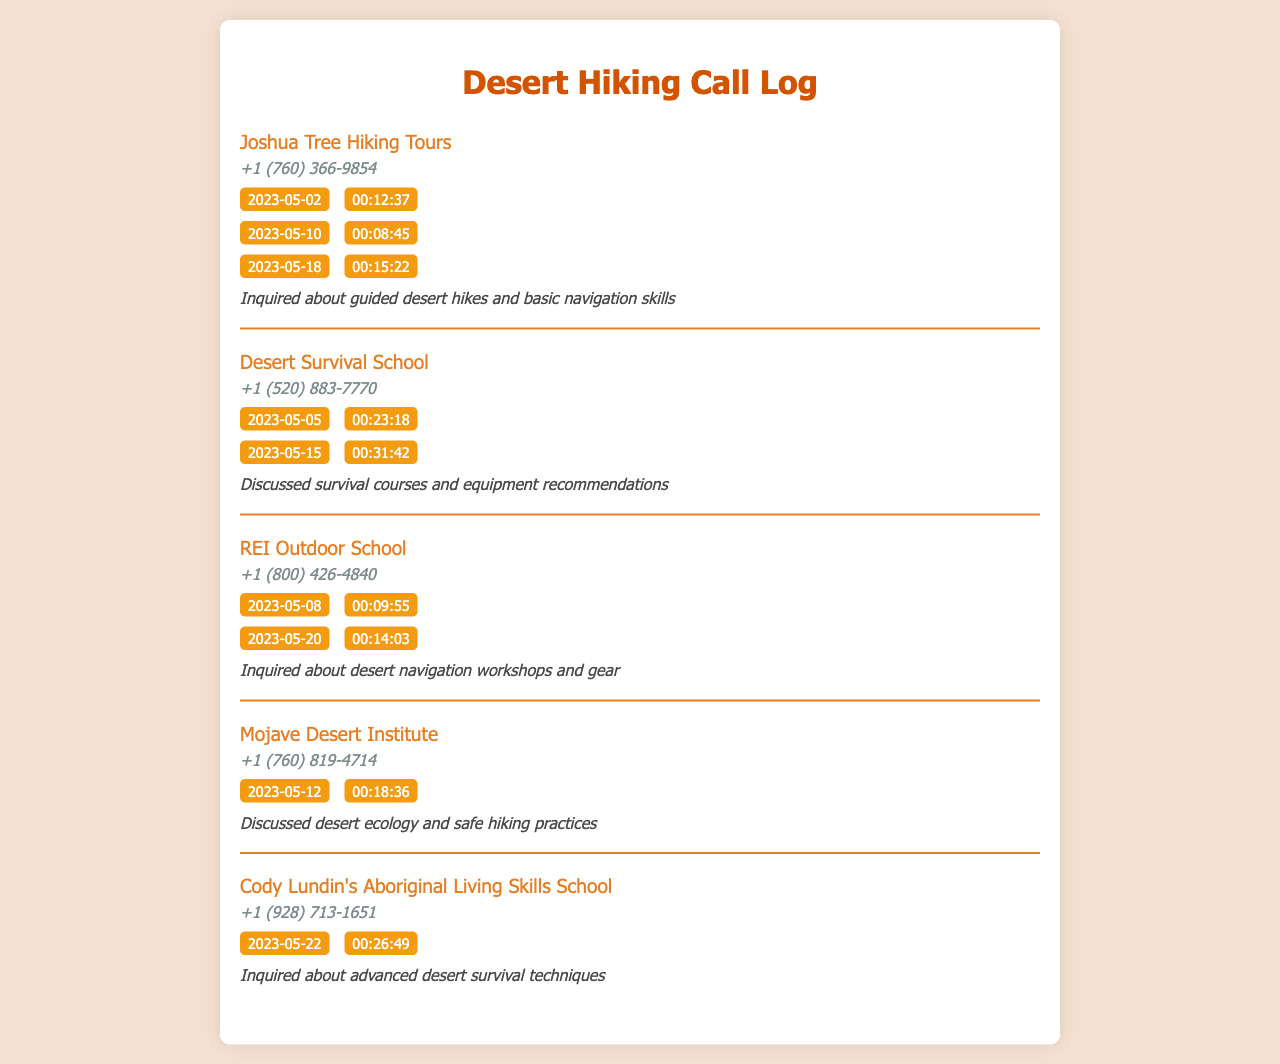What is the name of the first contact in the call log? The first contact in the call log is "Joshua Tree Hiking Tours".
Answer: Joshua Tree Hiking Tours How many total calls were made to the Desert Survival School? The Desert Survival School has two calls listed in the document.
Answer: 2 What is the duration of the longest call to Cody Lundin's Aboriginal Living Skills School? The longest call to Cody Lundin's Aboriginal Living Skills School lasted 26 minutes and 49 seconds.
Answer: 00:26:49 On what date was the last call made to REI Outdoor School? The last call to REI Outdoor School was made on May 20, 2023.
Answer: 2023-05-20 Which contact had the longest individual call duration? The longest individual call was to the Desert Survival School with a duration of 31 minutes and 42 seconds.
Answer: 00:31:42 How many contacts are listed in the call log? The document lists a total of five contacts in the call log.
Answer: 5 What is the phone number for Mojave Desert Institute? The phone number for Mojave Desert Institute is +1 (760) 819-4714.
Answer: +1 (760) 819-4714 Which contact is associated with inquiries about desert navigation workshops? The contact associated with inquiries about desert navigation workshops is REI Outdoor School.
Answer: REI Outdoor School What was discussed in the call with the Mojave Desert Institute? The call with the Mojave Desert Institute discussed desert ecology and safe hiking practices.
Answer: Desert ecology and safe hiking practices 